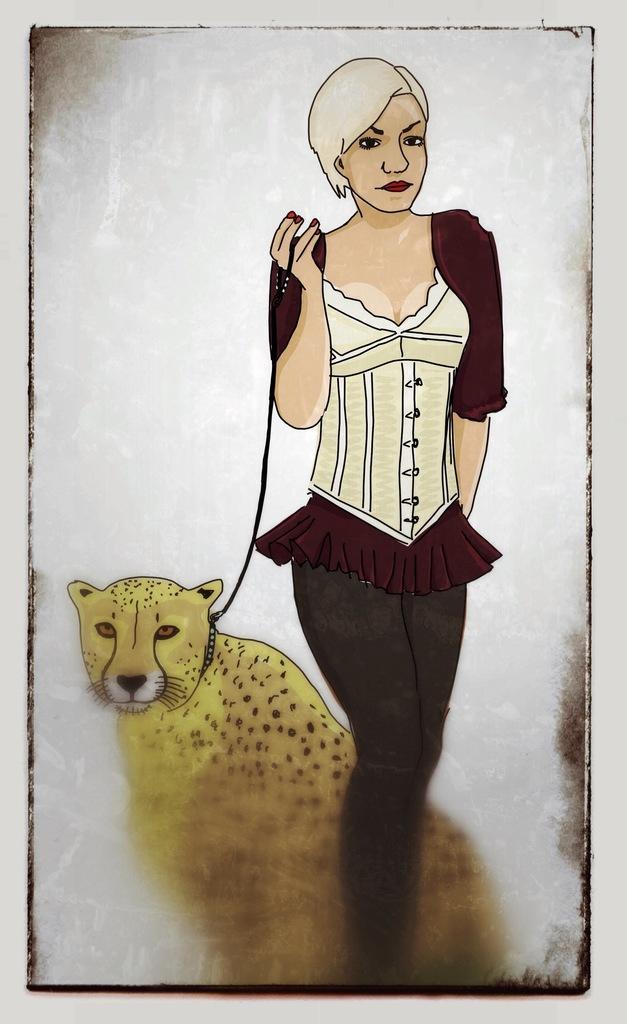Could you give a brief overview of what you see in this image? In this picture I can see an animated image of a woman standing and holding the rope, that is tied to the leopard. 